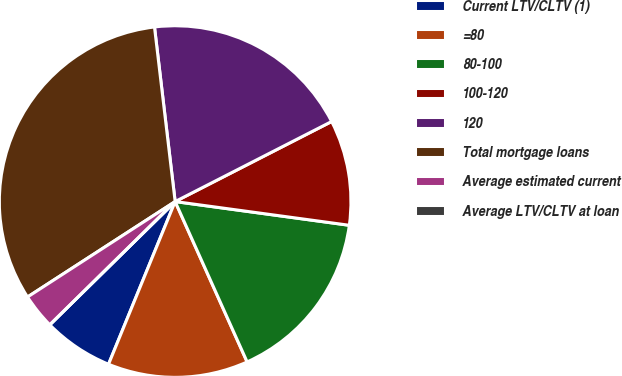<chart> <loc_0><loc_0><loc_500><loc_500><pie_chart><fcel>Current LTV/CLTV (1)<fcel>=80<fcel>80-100<fcel>100-120<fcel>120<fcel>Total mortgage loans<fcel>Average estimated current<fcel>Average LTV/CLTV at loan<nl><fcel>6.45%<fcel>12.9%<fcel>16.13%<fcel>9.68%<fcel>19.35%<fcel>32.26%<fcel>3.23%<fcel>0.0%<nl></chart> 